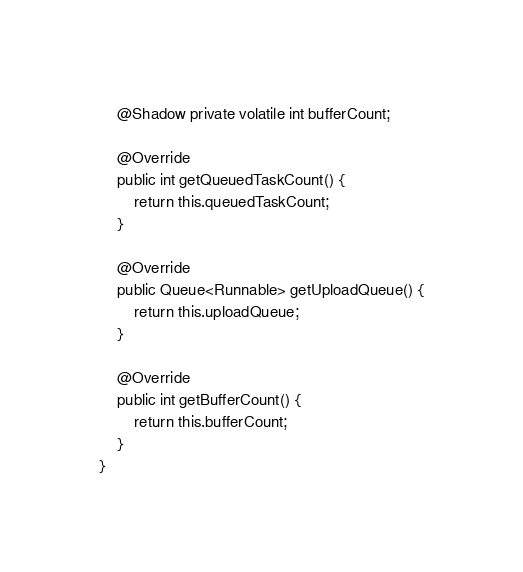Convert code to text. <code><loc_0><loc_0><loc_500><loc_500><_Java_>    @Shadow private volatile int bufferCount;

    @Override
    public int getQueuedTaskCount() {
        return this.queuedTaskCount;
    }

    @Override
    public Queue<Runnable> getUploadQueue() {
        return this.uploadQueue;
    }

    @Override
    public int getBufferCount() {
        return this.bufferCount;
    }
}
</code> 